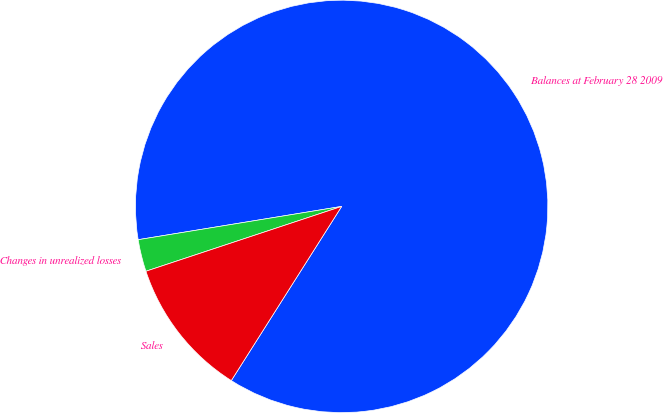Convert chart. <chart><loc_0><loc_0><loc_500><loc_500><pie_chart><fcel>Balances at February 28 2009<fcel>Changes in unrealized losses<fcel>Sales<nl><fcel>86.57%<fcel>2.51%<fcel>10.92%<nl></chart> 